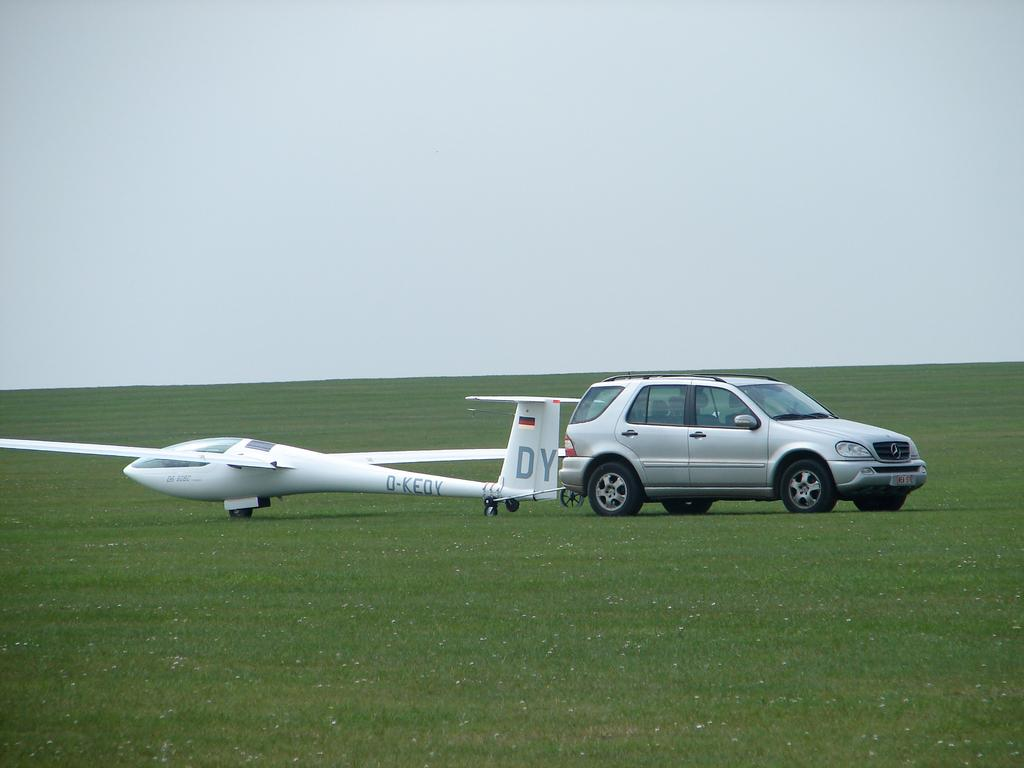<image>
Present a compact description of the photo's key features. the letters DY are on the plane on the green grass 